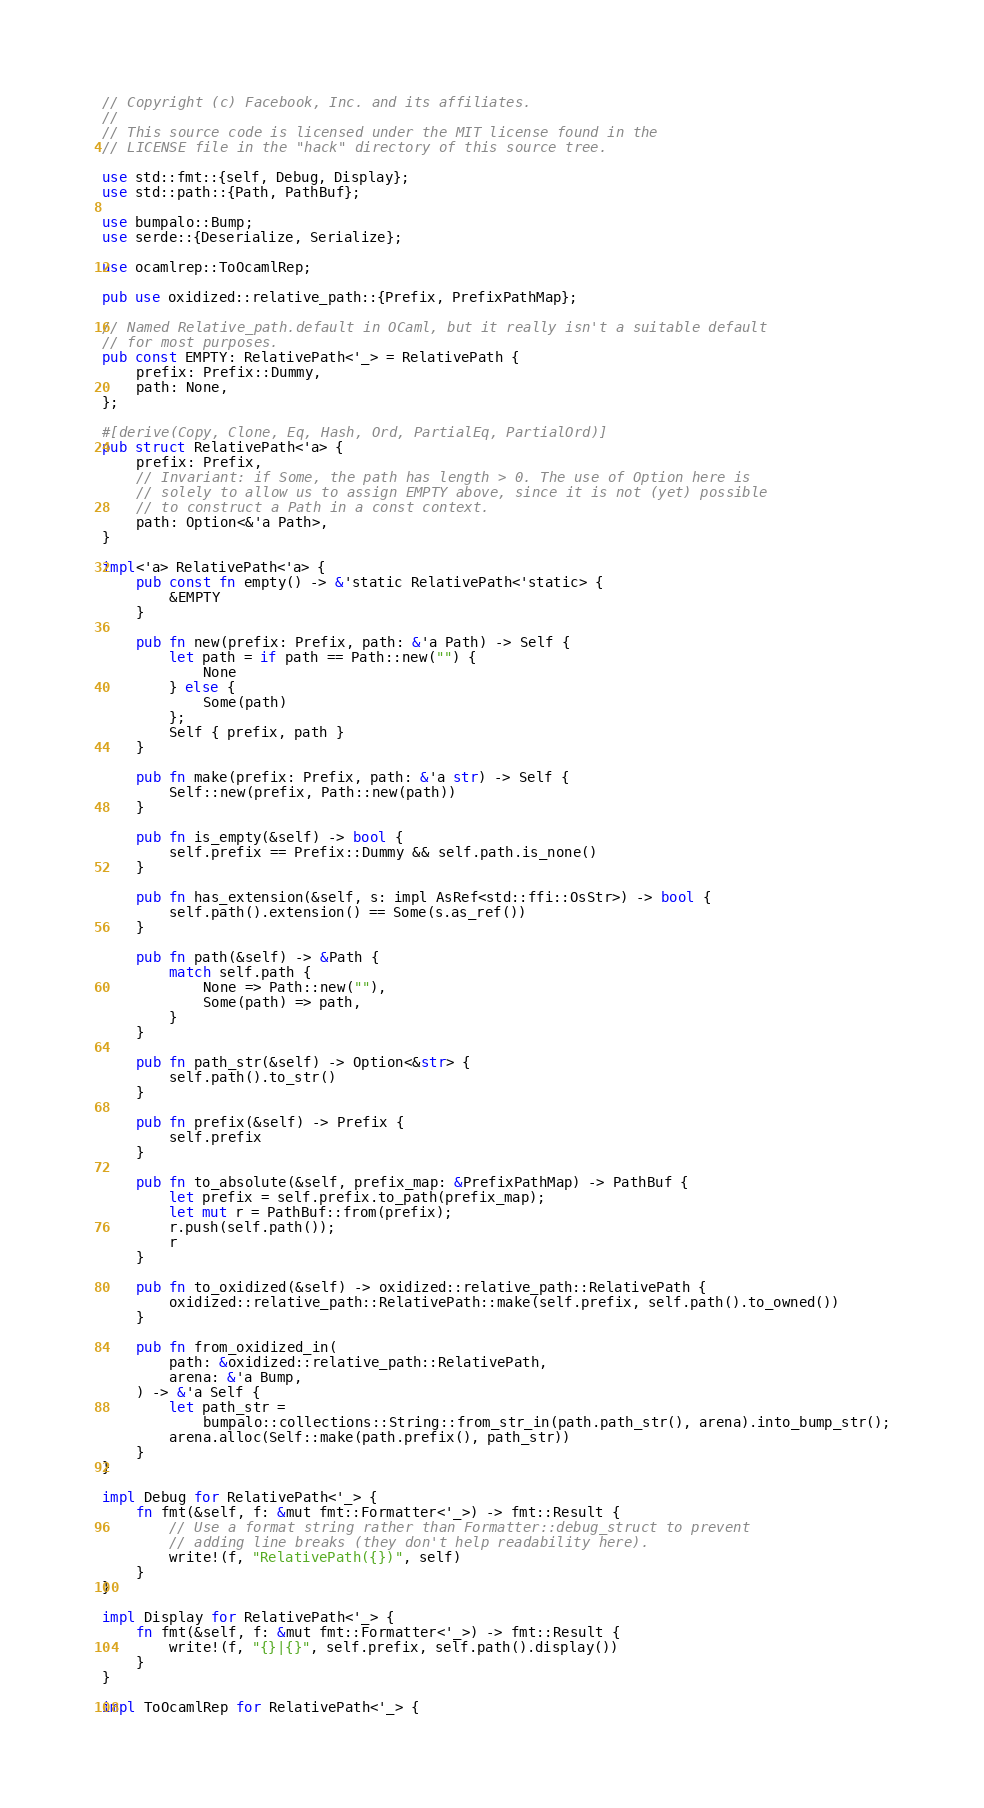<code> <loc_0><loc_0><loc_500><loc_500><_Rust_>// Copyright (c) Facebook, Inc. and its affiliates.
//
// This source code is licensed under the MIT license found in the
// LICENSE file in the "hack" directory of this source tree.

use std::fmt::{self, Debug, Display};
use std::path::{Path, PathBuf};

use bumpalo::Bump;
use serde::{Deserialize, Serialize};

use ocamlrep::ToOcamlRep;

pub use oxidized::relative_path::{Prefix, PrefixPathMap};

// Named Relative_path.default in OCaml, but it really isn't a suitable default
// for most purposes.
pub const EMPTY: RelativePath<'_> = RelativePath {
    prefix: Prefix::Dummy,
    path: None,
};

#[derive(Copy, Clone, Eq, Hash, Ord, PartialEq, PartialOrd)]
pub struct RelativePath<'a> {
    prefix: Prefix,
    // Invariant: if Some, the path has length > 0. The use of Option here is
    // solely to allow us to assign EMPTY above, since it is not (yet) possible
    // to construct a Path in a const context.
    path: Option<&'a Path>,
}

impl<'a> RelativePath<'a> {
    pub const fn empty() -> &'static RelativePath<'static> {
        &EMPTY
    }

    pub fn new(prefix: Prefix, path: &'a Path) -> Self {
        let path = if path == Path::new("") {
            None
        } else {
            Some(path)
        };
        Self { prefix, path }
    }

    pub fn make(prefix: Prefix, path: &'a str) -> Self {
        Self::new(prefix, Path::new(path))
    }

    pub fn is_empty(&self) -> bool {
        self.prefix == Prefix::Dummy && self.path.is_none()
    }

    pub fn has_extension(&self, s: impl AsRef<std::ffi::OsStr>) -> bool {
        self.path().extension() == Some(s.as_ref())
    }

    pub fn path(&self) -> &Path {
        match self.path {
            None => Path::new(""),
            Some(path) => path,
        }
    }

    pub fn path_str(&self) -> Option<&str> {
        self.path().to_str()
    }

    pub fn prefix(&self) -> Prefix {
        self.prefix
    }

    pub fn to_absolute(&self, prefix_map: &PrefixPathMap) -> PathBuf {
        let prefix = self.prefix.to_path(prefix_map);
        let mut r = PathBuf::from(prefix);
        r.push(self.path());
        r
    }

    pub fn to_oxidized(&self) -> oxidized::relative_path::RelativePath {
        oxidized::relative_path::RelativePath::make(self.prefix, self.path().to_owned())
    }

    pub fn from_oxidized_in(
        path: &oxidized::relative_path::RelativePath,
        arena: &'a Bump,
    ) -> &'a Self {
        let path_str =
            bumpalo::collections::String::from_str_in(path.path_str(), arena).into_bump_str();
        arena.alloc(Self::make(path.prefix(), path_str))
    }
}

impl Debug for RelativePath<'_> {
    fn fmt(&self, f: &mut fmt::Formatter<'_>) -> fmt::Result {
        // Use a format string rather than Formatter::debug_struct to prevent
        // adding line breaks (they don't help readability here).
        write!(f, "RelativePath({})", self)
    }
}

impl Display for RelativePath<'_> {
    fn fmt(&self, f: &mut fmt::Formatter<'_>) -> fmt::Result {
        write!(f, "{}|{}", self.prefix, self.path().display())
    }
}

impl ToOcamlRep for RelativePath<'_> {</code> 